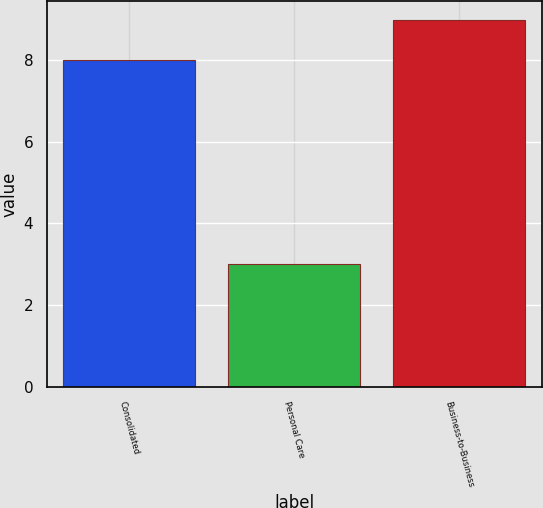<chart> <loc_0><loc_0><loc_500><loc_500><bar_chart><fcel>Consolidated<fcel>Personal Care<fcel>Business-to-Business<nl><fcel>8<fcel>3<fcel>9<nl></chart> 